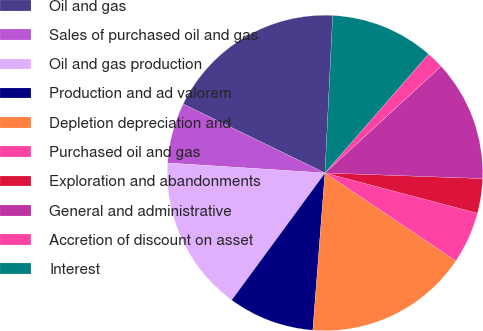<chart> <loc_0><loc_0><loc_500><loc_500><pie_chart><fcel>Oil and gas<fcel>Sales of purchased oil and gas<fcel>Oil and gas production<fcel>Production and ad valorem<fcel>Depletion depreciation and<fcel>Purchased oil and gas<fcel>Exploration and abandonments<fcel>General and administrative<fcel>Accretion of discount on asset<fcel>Interest<nl><fcel>18.58%<fcel>6.19%<fcel>15.93%<fcel>8.85%<fcel>16.81%<fcel>5.31%<fcel>3.54%<fcel>12.39%<fcel>1.77%<fcel>10.62%<nl></chart> 